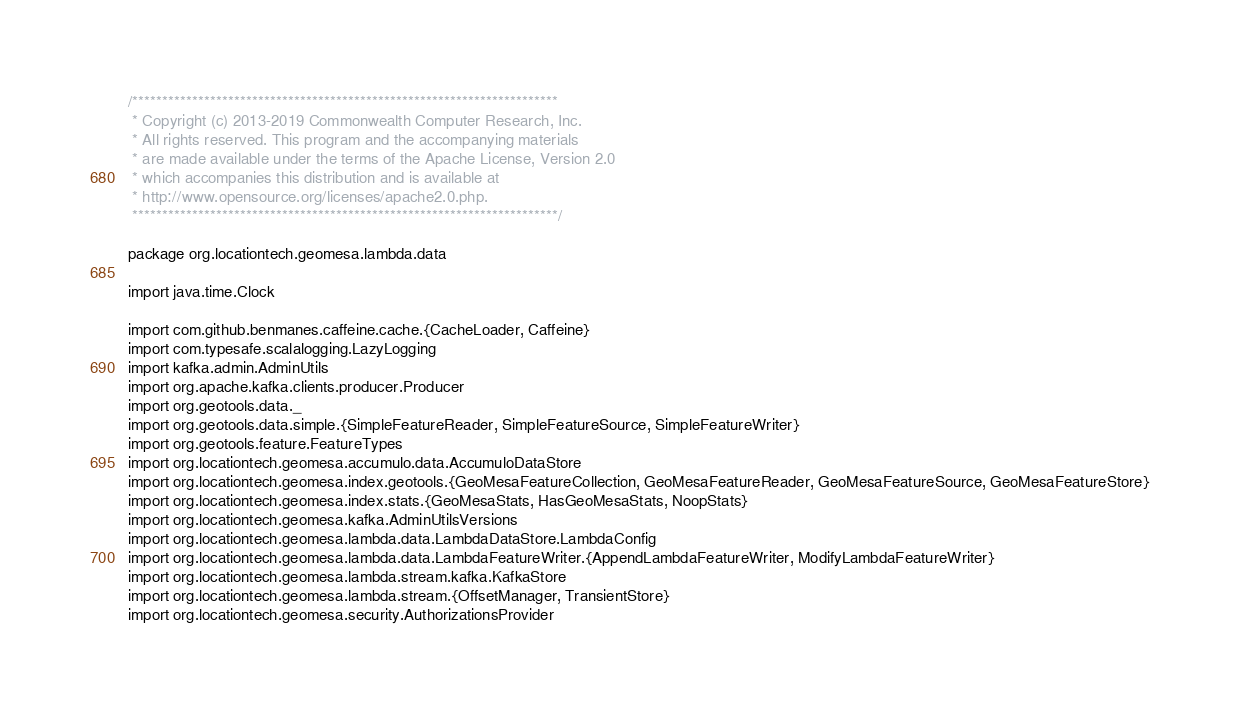<code> <loc_0><loc_0><loc_500><loc_500><_Scala_>/***********************************************************************
 * Copyright (c) 2013-2019 Commonwealth Computer Research, Inc.
 * All rights reserved. This program and the accompanying materials
 * are made available under the terms of the Apache License, Version 2.0
 * which accompanies this distribution and is available at
 * http://www.opensource.org/licenses/apache2.0.php.
 ***********************************************************************/

package org.locationtech.geomesa.lambda.data

import java.time.Clock

import com.github.benmanes.caffeine.cache.{CacheLoader, Caffeine}
import com.typesafe.scalalogging.LazyLogging
import kafka.admin.AdminUtils
import org.apache.kafka.clients.producer.Producer
import org.geotools.data._
import org.geotools.data.simple.{SimpleFeatureReader, SimpleFeatureSource, SimpleFeatureWriter}
import org.geotools.feature.FeatureTypes
import org.locationtech.geomesa.accumulo.data.AccumuloDataStore
import org.locationtech.geomesa.index.geotools.{GeoMesaFeatureCollection, GeoMesaFeatureReader, GeoMesaFeatureSource, GeoMesaFeatureStore}
import org.locationtech.geomesa.index.stats.{GeoMesaStats, HasGeoMesaStats, NoopStats}
import org.locationtech.geomesa.kafka.AdminUtilsVersions
import org.locationtech.geomesa.lambda.data.LambdaDataStore.LambdaConfig
import org.locationtech.geomesa.lambda.data.LambdaFeatureWriter.{AppendLambdaFeatureWriter, ModifyLambdaFeatureWriter}
import org.locationtech.geomesa.lambda.stream.kafka.KafkaStore
import org.locationtech.geomesa.lambda.stream.{OffsetManager, TransientStore}
import org.locationtech.geomesa.security.AuthorizationsProvider</code> 